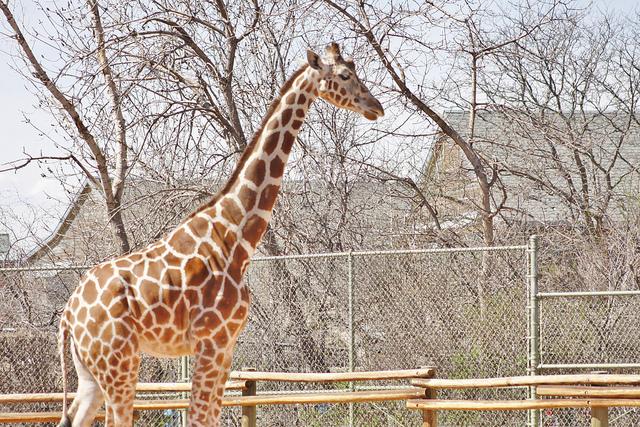Is the animal shown a reptile?
Keep it brief. No. Are there trees in this photo?
Give a very brief answer. Yes. How many different types of fences are there?
Give a very brief answer. 2. 